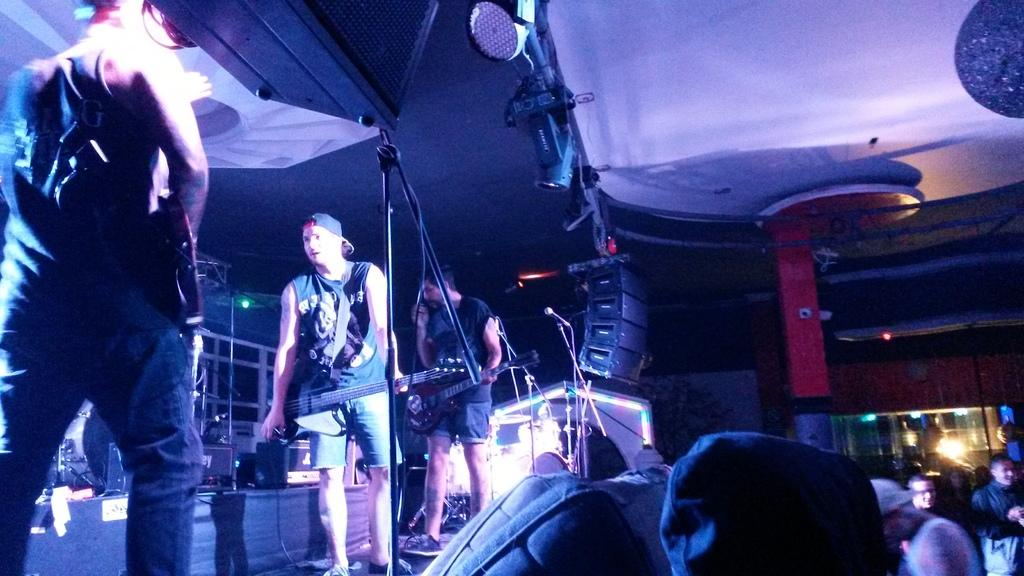How many people are present in the image? There are three people in the image. Where are the three people located? The three people are standing on a stage. What are the people on stage holding? The people on stage are holding guitars. Can you describe the audience in the image? There is a group of people standing in front of the stage. What type of pipe can be seen in the image? There is no pipe present in the image. Can you solve the riddle that is being told on stage in the image? There is no riddle being told on stage in the image. 